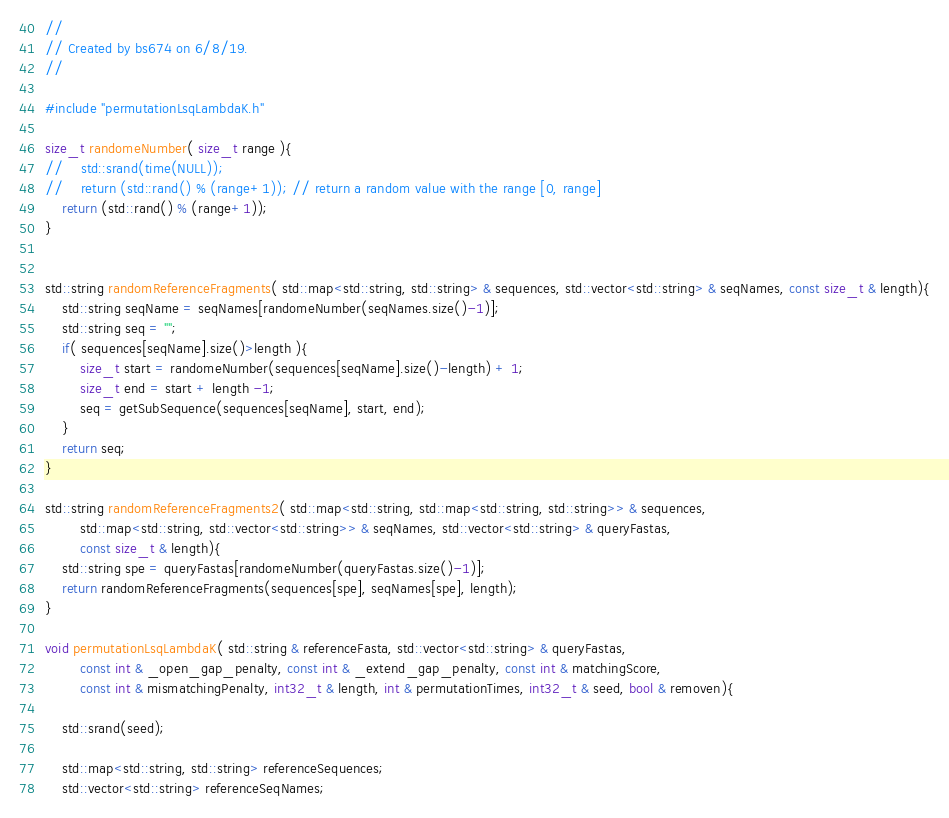<code> <loc_0><loc_0><loc_500><loc_500><_C++_>//
// Created by bs674 on 6/8/19.
//

#include "permutationLsqLambdaK.h"

size_t randomeNumber( size_t range ){
//    std::srand(time(NULL));
//    return (std::rand() % (range+1)); // return a random value with the range [0, range]
    return (std::rand() % (range+1));
}


std::string randomReferenceFragments( std::map<std::string, std::string> & sequences, std::vector<std::string> & seqNames, const size_t & length){
    std::string seqName = seqNames[randomeNumber(seqNames.size()-1)];
    std::string seq = "";
    if( sequences[seqName].size()>length ){
        size_t start = randomeNumber(sequences[seqName].size()-length) + 1;
        size_t end = start + length -1;
        seq = getSubSequence(sequences[seqName], start, end);
    }
    return seq;
}

std::string randomReferenceFragments2( std::map<std::string, std::map<std::string, std::string>> & sequences,
        std::map<std::string, std::vector<std::string>> & seqNames, std::vector<std::string> & queryFastas,
        const size_t & length){
    std::string spe = queryFastas[randomeNumber(queryFastas.size()-1)];
    return randomReferenceFragments(sequences[spe], seqNames[spe], length);
}

void permutationLsqLambdaK( std::string & referenceFasta, std::vector<std::string> & queryFastas,
        const int & _open_gap_penalty, const int & _extend_gap_penalty, const int & matchingScore,
        const int & mismatchingPenalty, int32_t & length, int & permutationTimes, int32_t & seed, bool & removen){

    std::srand(seed);

    std::map<std::string, std::string> referenceSequences;
    std::vector<std::string> referenceSeqNames;</code> 